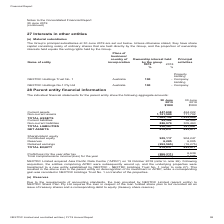According to Nextdc's financial document, Do the company have any guarantees in relation to the debts of subsidiaries as of June 30, 2019? did not have any guarantees in relation to the debts of subsidiaries. The document states: "As at 30 June 2019, NEXTDC Limited did not have any guarantees in relation to the debts of subsidiaries...." Also, How much was the total loss for 2019 after tax? According to the financial document, 266,311 (in thousands). The relevant text states: "(266,311) 6,639..." Also, How much was the total assets in 2018? According to the financial document, 1,235,924 (in thousands). The relevant text states: "1,569,198 1,235,924 63,382 36,484 886,979 305,463..." Also, can you calculate: What was the percentage change in total liabilities between 2018 and 2019? To answer this question, I need to perform calculations using the financial data. The calculation is: (950,361 - 341,947) / 341,947 , which equals 177.93 (percentage). This is based on the information: "950,361 341,947 618,837 893,977 950,361 341,947 618,837 893,977..." The key data points involved are: 341,947, 950,361. Also, can you calculate: What was the difference between current and non-current assets in 2018? Based on the calculation: 771,702 - 464,222 , the result is 307480 (in thousands). This is based on the information: "447,698 464,222 1,121,500 771,702 447,698 464,222 1,121,500 771,702..." The key data points involved are: 464,222, 771,702. Also, can you calculate: What was the percentage change in reserves between 2018 and 2019? To answer this question, I need to perform calculations using the financial data. The calculation is: (6,285 - 6,005) / 6,005 , which equals 4.66 (percentage). This is based on the information: "905,117 904,247 6,285 6,005 905,117 904,247 6,285 6,005..." The key data points involved are: 6,005, 6,285. 